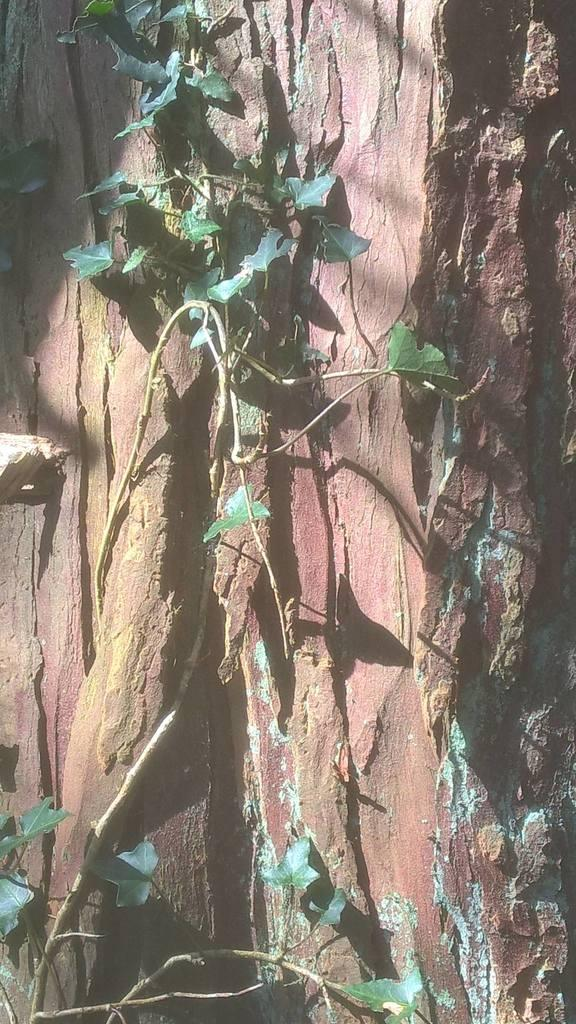What is present on the bark in the image? There is a creep on the bark in the image. Who is leading the discussion about the creep in the image? There is no discussion about the creep in the image, as it is a static image and not a live event. What is the name of the creep in the image? The creep in the image is not a named entity, and it is not possible to determine its name from the image alone. 